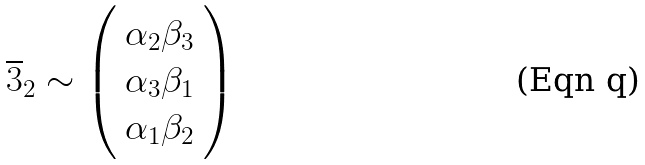Convert formula to latex. <formula><loc_0><loc_0><loc_500><loc_500>\overline { 3 } _ { 2 } \sim \left ( \begin{array} { c } \alpha _ { 2 } \beta _ { 3 } \\ \alpha _ { 3 } \beta _ { 1 } \\ \alpha _ { 1 } \beta _ { 2 } \end{array} \right )</formula> 